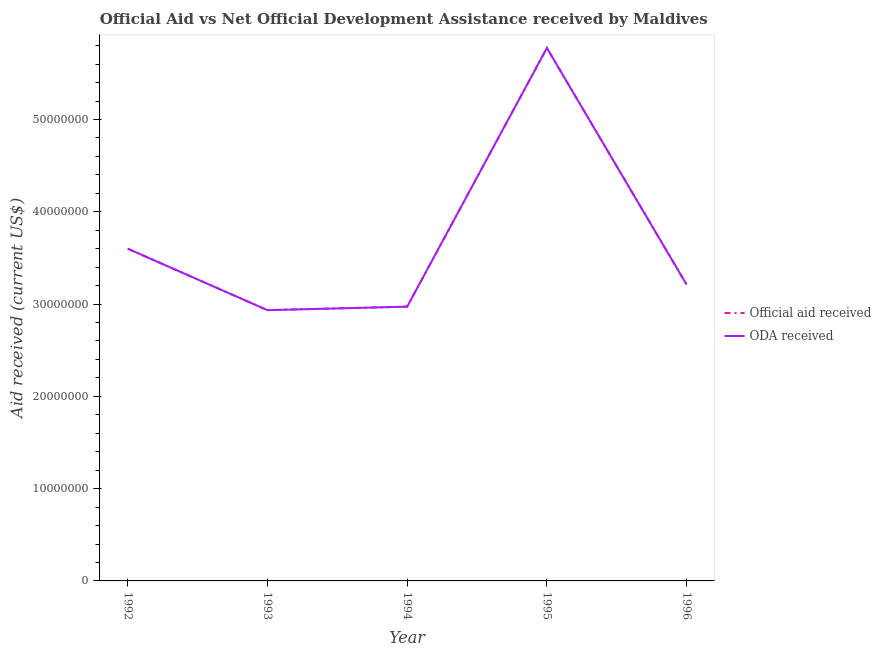What is the oda received in 1994?
Make the answer very short. 2.97e+07. Across all years, what is the maximum official aid received?
Your response must be concise. 5.78e+07. Across all years, what is the minimum oda received?
Your response must be concise. 2.93e+07. In which year was the official aid received minimum?
Your answer should be compact. 1993. What is the total oda received in the graph?
Provide a succinct answer. 1.85e+08. What is the difference between the official aid received in 1992 and that in 1996?
Ensure brevity in your answer.  3.89e+06. What is the difference between the oda received in 1996 and the official aid received in 1995?
Offer a very short reply. -2.56e+07. What is the average oda received per year?
Give a very brief answer. 3.70e+07. What is the ratio of the oda received in 1993 to that in 1995?
Provide a succinct answer. 0.51. Is the oda received in 1992 less than that in 1995?
Provide a succinct answer. Yes. Is the difference between the official aid received in 1993 and 1996 greater than the difference between the oda received in 1993 and 1996?
Ensure brevity in your answer.  No. What is the difference between the highest and the second highest oda received?
Offer a terse response. 2.18e+07. What is the difference between the highest and the lowest official aid received?
Give a very brief answer. 2.84e+07. Is the oda received strictly greater than the official aid received over the years?
Your answer should be compact. No. Is the official aid received strictly less than the oda received over the years?
Provide a short and direct response. No. How many lines are there?
Offer a terse response. 2. Does the graph contain any zero values?
Ensure brevity in your answer.  No. Where does the legend appear in the graph?
Offer a very short reply. Center right. How many legend labels are there?
Your answer should be compact. 2. What is the title of the graph?
Your answer should be very brief. Official Aid vs Net Official Development Assistance received by Maldives . What is the label or title of the X-axis?
Your answer should be very brief. Year. What is the label or title of the Y-axis?
Provide a succinct answer. Aid received (current US$). What is the Aid received (current US$) in Official aid received in 1992?
Offer a very short reply. 3.60e+07. What is the Aid received (current US$) in ODA received in 1992?
Ensure brevity in your answer.  3.60e+07. What is the Aid received (current US$) in Official aid received in 1993?
Ensure brevity in your answer.  2.93e+07. What is the Aid received (current US$) in ODA received in 1993?
Give a very brief answer. 2.93e+07. What is the Aid received (current US$) of Official aid received in 1994?
Make the answer very short. 2.97e+07. What is the Aid received (current US$) of ODA received in 1994?
Keep it short and to the point. 2.97e+07. What is the Aid received (current US$) of Official aid received in 1995?
Give a very brief answer. 5.78e+07. What is the Aid received (current US$) in ODA received in 1995?
Ensure brevity in your answer.  5.78e+07. What is the Aid received (current US$) in Official aid received in 1996?
Ensure brevity in your answer.  3.21e+07. What is the Aid received (current US$) of ODA received in 1996?
Make the answer very short. 3.21e+07. Across all years, what is the maximum Aid received (current US$) in Official aid received?
Provide a short and direct response. 5.78e+07. Across all years, what is the maximum Aid received (current US$) in ODA received?
Make the answer very short. 5.78e+07. Across all years, what is the minimum Aid received (current US$) in Official aid received?
Offer a terse response. 2.93e+07. Across all years, what is the minimum Aid received (current US$) in ODA received?
Offer a very short reply. 2.93e+07. What is the total Aid received (current US$) of Official aid received in the graph?
Offer a very short reply. 1.85e+08. What is the total Aid received (current US$) of ODA received in the graph?
Provide a short and direct response. 1.85e+08. What is the difference between the Aid received (current US$) in Official aid received in 1992 and that in 1993?
Provide a succinct answer. 6.66e+06. What is the difference between the Aid received (current US$) of ODA received in 1992 and that in 1993?
Provide a succinct answer. 6.66e+06. What is the difference between the Aid received (current US$) of Official aid received in 1992 and that in 1994?
Keep it short and to the point. 6.28e+06. What is the difference between the Aid received (current US$) of ODA received in 1992 and that in 1994?
Give a very brief answer. 6.28e+06. What is the difference between the Aid received (current US$) in Official aid received in 1992 and that in 1995?
Offer a terse response. -2.18e+07. What is the difference between the Aid received (current US$) in ODA received in 1992 and that in 1995?
Give a very brief answer. -2.18e+07. What is the difference between the Aid received (current US$) in Official aid received in 1992 and that in 1996?
Ensure brevity in your answer.  3.89e+06. What is the difference between the Aid received (current US$) of ODA received in 1992 and that in 1996?
Offer a terse response. 3.89e+06. What is the difference between the Aid received (current US$) of Official aid received in 1993 and that in 1994?
Your answer should be very brief. -3.80e+05. What is the difference between the Aid received (current US$) of ODA received in 1993 and that in 1994?
Offer a terse response. -3.80e+05. What is the difference between the Aid received (current US$) of Official aid received in 1993 and that in 1995?
Offer a terse response. -2.84e+07. What is the difference between the Aid received (current US$) of ODA received in 1993 and that in 1995?
Your answer should be compact. -2.84e+07. What is the difference between the Aid received (current US$) in Official aid received in 1993 and that in 1996?
Your response must be concise. -2.77e+06. What is the difference between the Aid received (current US$) of ODA received in 1993 and that in 1996?
Offer a very short reply. -2.77e+06. What is the difference between the Aid received (current US$) of Official aid received in 1994 and that in 1995?
Keep it short and to the point. -2.80e+07. What is the difference between the Aid received (current US$) in ODA received in 1994 and that in 1995?
Keep it short and to the point. -2.80e+07. What is the difference between the Aid received (current US$) in Official aid received in 1994 and that in 1996?
Offer a very short reply. -2.39e+06. What is the difference between the Aid received (current US$) of ODA received in 1994 and that in 1996?
Keep it short and to the point. -2.39e+06. What is the difference between the Aid received (current US$) of Official aid received in 1995 and that in 1996?
Your response must be concise. 2.56e+07. What is the difference between the Aid received (current US$) of ODA received in 1995 and that in 1996?
Your answer should be compact. 2.56e+07. What is the difference between the Aid received (current US$) of Official aid received in 1992 and the Aid received (current US$) of ODA received in 1993?
Offer a terse response. 6.66e+06. What is the difference between the Aid received (current US$) of Official aid received in 1992 and the Aid received (current US$) of ODA received in 1994?
Keep it short and to the point. 6.28e+06. What is the difference between the Aid received (current US$) of Official aid received in 1992 and the Aid received (current US$) of ODA received in 1995?
Give a very brief answer. -2.18e+07. What is the difference between the Aid received (current US$) of Official aid received in 1992 and the Aid received (current US$) of ODA received in 1996?
Your answer should be compact. 3.89e+06. What is the difference between the Aid received (current US$) in Official aid received in 1993 and the Aid received (current US$) in ODA received in 1994?
Your answer should be compact. -3.80e+05. What is the difference between the Aid received (current US$) in Official aid received in 1993 and the Aid received (current US$) in ODA received in 1995?
Offer a terse response. -2.84e+07. What is the difference between the Aid received (current US$) of Official aid received in 1993 and the Aid received (current US$) of ODA received in 1996?
Keep it short and to the point. -2.77e+06. What is the difference between the Aid received (current US$) of Official aid received in 1994 and the Aid received (current US$) of ODA received in 1995?
Give a very brief answer. -2.80e+07. What is the difference between the Aid received (current US$) of Official aid received in 1994 and the Aid received (current US$) of ODA received in 1996?
Your answer should be compact. -2.39e+06. What is the difference between the Aid received (current US$) in Official aid received in 1995 and the Aid received (current US$) in ODA received in 1996?
Provide a succinct answer. 2.56e+07. What is the average Aid received (current US$) in Official aid received per year?
Your answer should be compact. 3.70e+07. What is the average Aid received (current US$) of ODA received per year?
Offer a very short reply. 3.70e+07. In the year 1992, what is the difference between the Aid received (current US$) in Official aid received and Aid received (current US$) in ODA received?
Keep it short and to the point. 0. In the year 1994, what is the difference between the Aid received (current US$) in Official aid received and Aid received (current US$) in ODA received?
Your answer should be compact. 0. In the year 1995, what is the difference between the Aid received (current US$) in Official aid received and Aid received (current US$) in ODA received?
Ensure brevity in your answer.  0. What is the ratio of the Aid received (current US$) of Official aid received in 1992 to that in 1993?
Your answer should be very brief. 1.23. What is the ratio of the Aid received (current US$) of ODA received in 1992 to that in 1993?
Your answer should be compact. 1.23. What is the ratio of the Aid received (current US$) in Official aid received in 1992 to that in 1994?
Offer a very short reply. 1.21. What is the ratio of the Aid received (current US$) of ODA received in 1992 to that in 1994?
Your answer should be very brief. 1.21. What is the ratio of the Aid received (current US$) of Official aid received in 1992 to that in 1995?
Make the answer very short. 0.62. What is the ratio of the Aid received (current US$) in ODA received in 1992 to that in 1995?
Your response must be concise. 0.62. What is the ratio of the Aid received (current US$) in Official aid received in 1992 to that in 1996?
Your answer should be very brief. 1.12. What is the ratio of the Aid received (current US$) in ODA received in 1992 to that in 1996?
Ensure brevity in your answer.  1.12. What is the ratio of the Aid received (current US$) of Official aid received in 1993 to that in 1994?
Keep it short and to the point. 0.99. What is the ratio of the Aid received (current US$) in ODA received in 1993 to that in 1994?
Keep it short and to the point. 0.99. What is the ratio of the Aid received (current US$) in Official aid received in 1993 to that in 1995?
Provide a short and direct response. 0.51. What is the ratio of the Aid received (current US$) in ODA received in 1993 to that in 1995?
Your answer should be very brief. 0.51. What is the ratio of the Aid received (current US$) in Official aid received in 1993 to that in 1996?
Provide a short and direct response. 0.91. What is the ratio of the Aid received (current US$) of ODA received in 1993 to that in 1996?
Offer a very short reply. 0.91. What is the ratio of the Aid received (current US$) in Official aid received in 1994 to that in 1995?
Offer a very short reply. 0.51. What is the ratio of the Aid received (current US$) of ODA received in 1994 to that in 1995?
Make the answer very short. 0.51. What is the ratio of the Aid received (current US$) in Official aid received in 1994 to that in 1996?
Make the answer very short. 0.93. What is the ratio of the Aid received (current US$) of ODA received in 1994 to that in 1996?
Your answer should be compact. 0.93. What is the ratio of the Aid received (current US$) of Official aid received in 1995 to that in 1996?
Provide a short and direct response. 1.8. What is the ratio of the Aid received (current US$) in ODA received in 1995 to that in 1996?
Offer a terse response. 1.8. What is the difference between the highest and the second highest Aid received (current US$) of Official aid received?
Keep it short and to the point. 2.18e+07. What is the difference between the highest and the second highest Aid received (current US$) in ODA received?
Your answer should be compact. 2.18e+07. What is the difference between the highest and the lowest Aid received (current US$) in Official aid received?
Offer a terse response. 2.84e+07. What is the difference between the highest and the lowest Aid received (current US$) of ODA received?
Your response must be concise. 2.84e+07. 